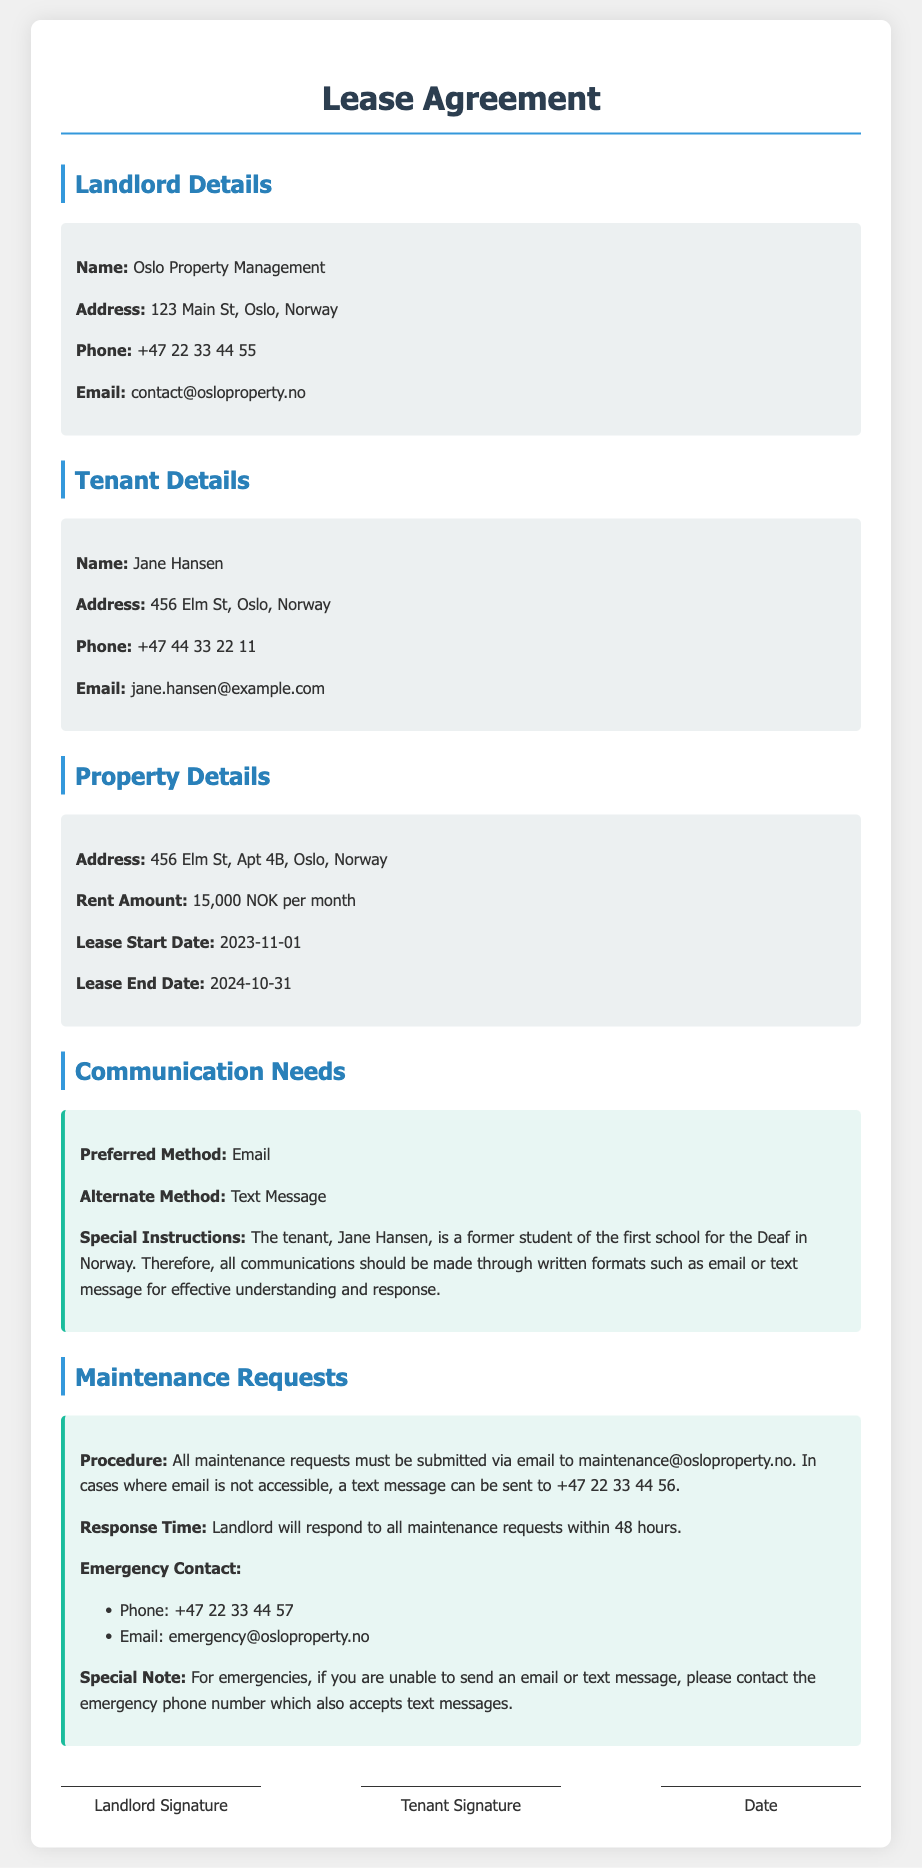What is the name of the landlord? The name of the landlord is mentioned in the "Landlord Details" section of the document.
Answer: Oslo Property Management What is the preferred method of communication? The preferred method of communication is specified in the "Communication Needs" section.
Answer: Email What is the address of the tenant? The tenant's address is found in the "Tenant Details" section of the document.
Answer: 456 Elm St, Oslo, Norway How much is the monthly rent? The monthly rent amount is outlined in the "Property Details" section.
Answer: 15,000 NOK per month When does the lease start? The lease start date is specified in the "Property Details" section.
Answer: 2023-11-01 What is the response time for maintenance requests? The response time for maintenance requests is mentioned in the "Maintenance Requests" section.
Answer: 48 hours What is the emergency contact email? The emergency contact email is listed in the "Maintenance Requests" section of the document.
Answer: emergency@osloproperty.no What special instruction is given for communication? The special instruction for communication is detailed in the "Communication Needs" section.
Answer: Written formats such as email or text message What should tenants do if they cannot send an email? The document specifies an alternative in the "Maintenance Requests" section.
Answer: Send a text message to +47 22 33 44 56 